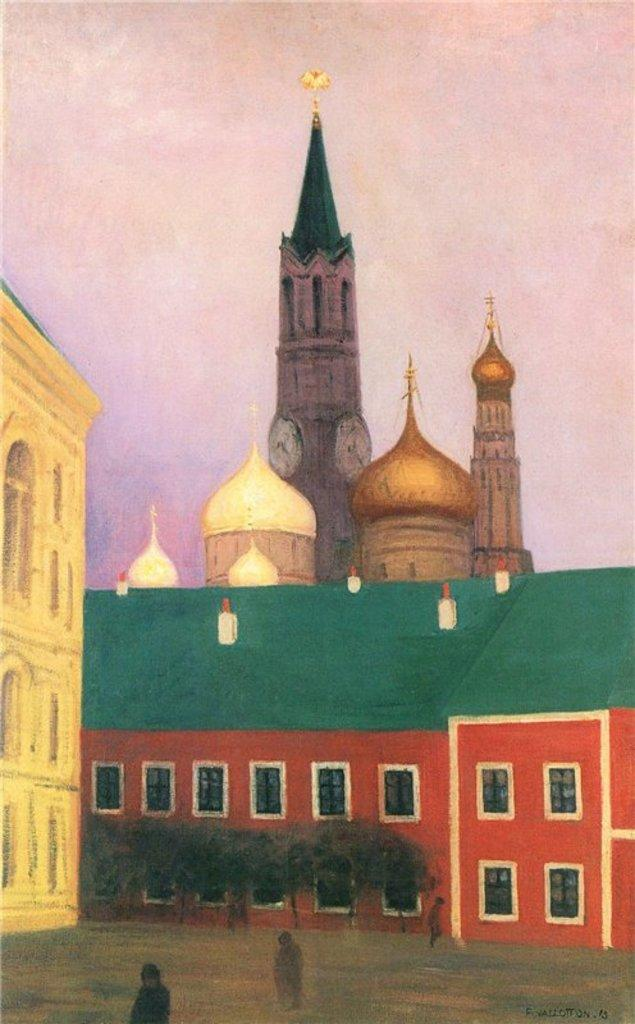What is the main subject of the image? The main subject of the image is a painting. What elements are included in the painting? The painting contains buildings, windows, trees, people, and the sky. What is the income of the snails depicted in the painting? There are no snails depicted in the painting; it features buildings, windows, trees, people, and the sky. 